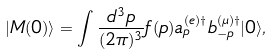<formula> <loc_0><loc_0><loc_500><loc_500>| M ( 0 ) \rangle = \int \frac { d ^ { 3 } p } { ( 2 \pi ) ^ { 3 } } f ( p ) a _ { p } ^ { ( e ) \dagger } b _ { - p } ^ { ( \mu ) \dagger } | 0 \rangle ,</formula> 